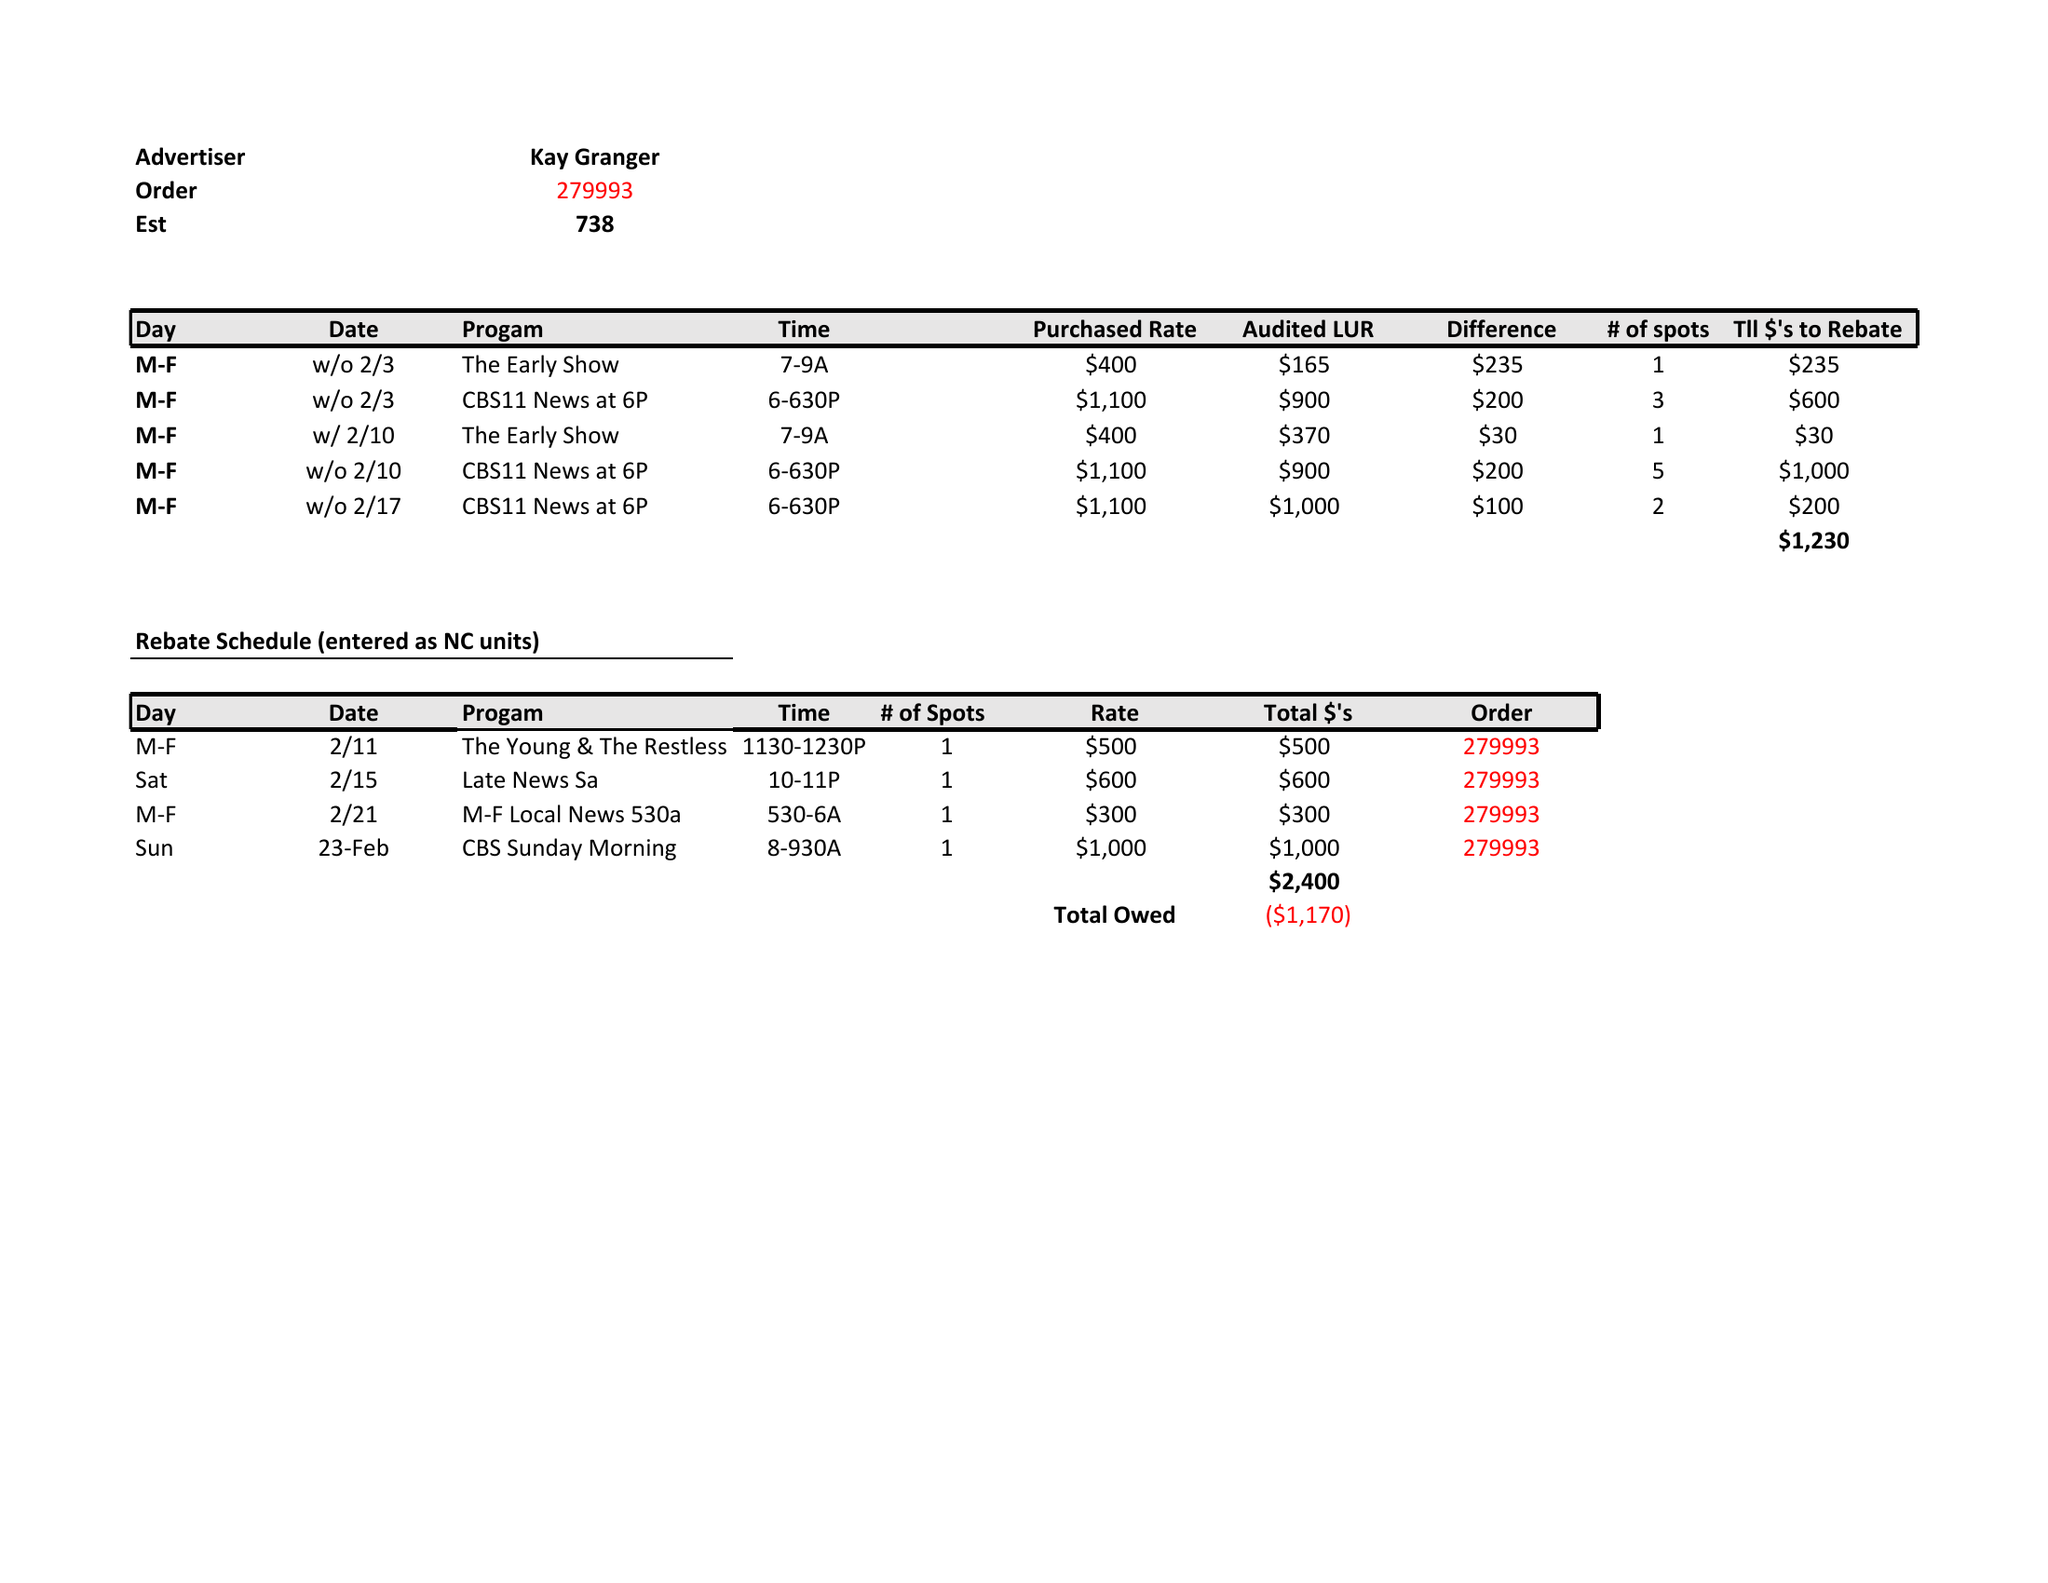What is the value for the flight_to?
Answer the question using a single word or phrase. None 